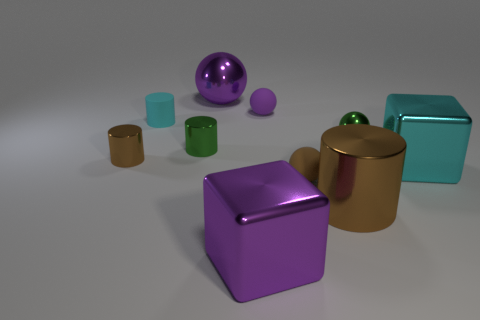Subtract 1 cylinders. How many cylinders are left? 3 Subtract all balls. How many objects are left? 6 Add 4 big yellow matte cylinders. How many big yellow matte cylinders exist? 4 Subtract 1 green cylinders. How many objects are left? 9 Subtract all big green shiny balls. Subtract all cyan objects. How many objects are left? 8 Add 5 purple blocks. How many purple blocks are left? 6 